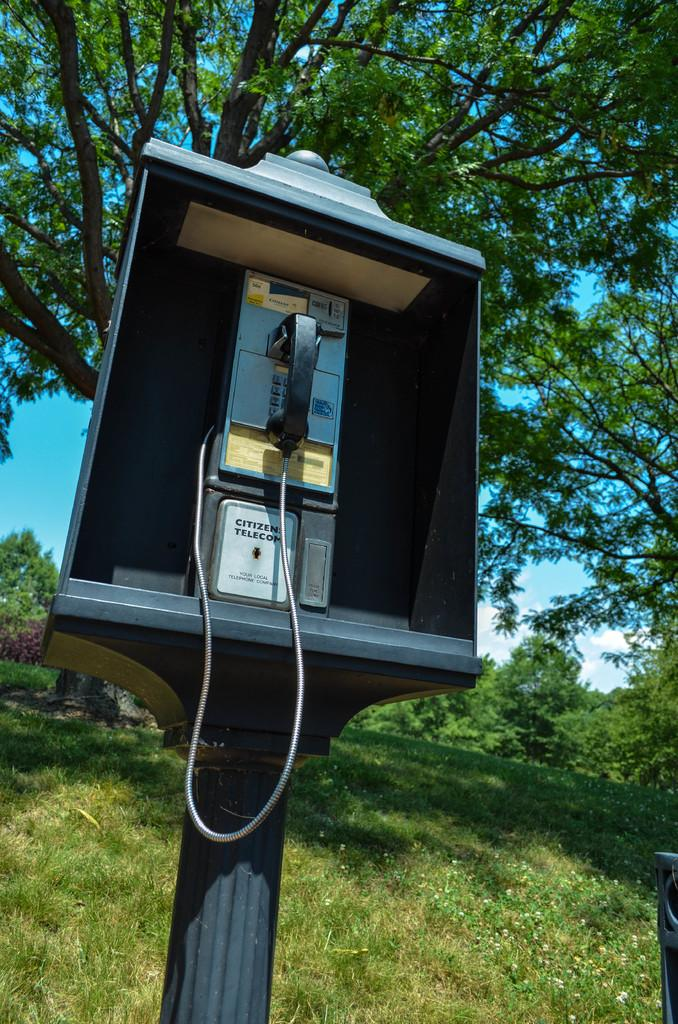What structure is present in the image? There is a telephone booth in the image. What is connected to the telephone booth? There is a pole associated with the telephone booth. What type of vegetation can be seen in the image? Trees are visible in the image. What is visible in the background of the image? The sky is visible in the background of the image. What type of cake is being served on the train in the image? There is no cake or train present in the image; it features a telephone booth and trees. What form does the telephone booth take in the image? The telephone booth is a physical structure, not a form or shape. 